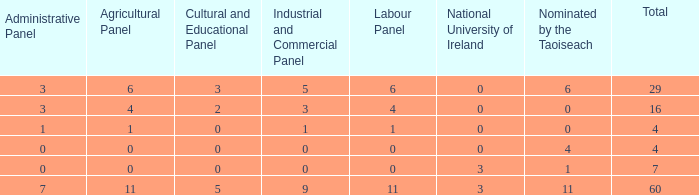What is the mean administrative board of the composition appointed by taoiseach 0 times with a total below 4? None. 